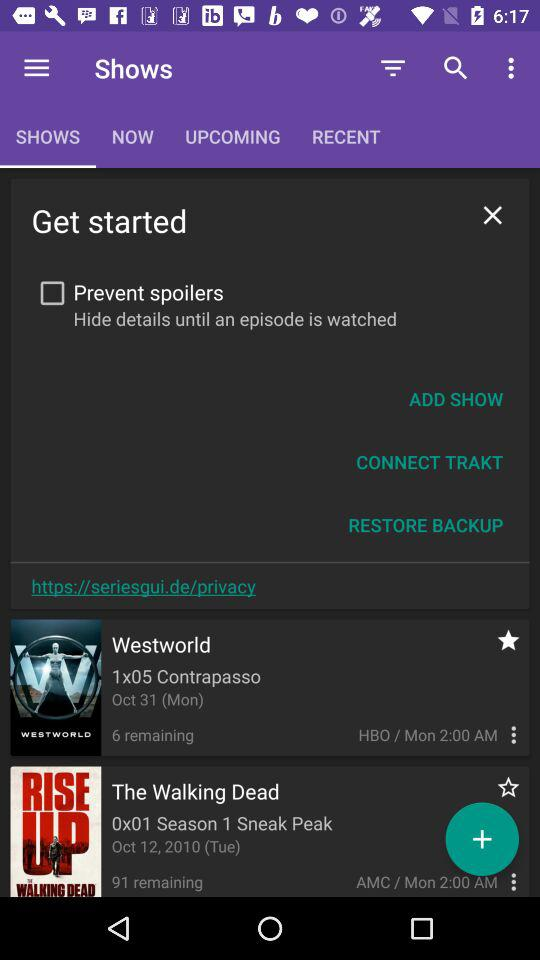How many episodes are remaining for The Walking Dead?
Answer the question using a single word or phrase. 91 